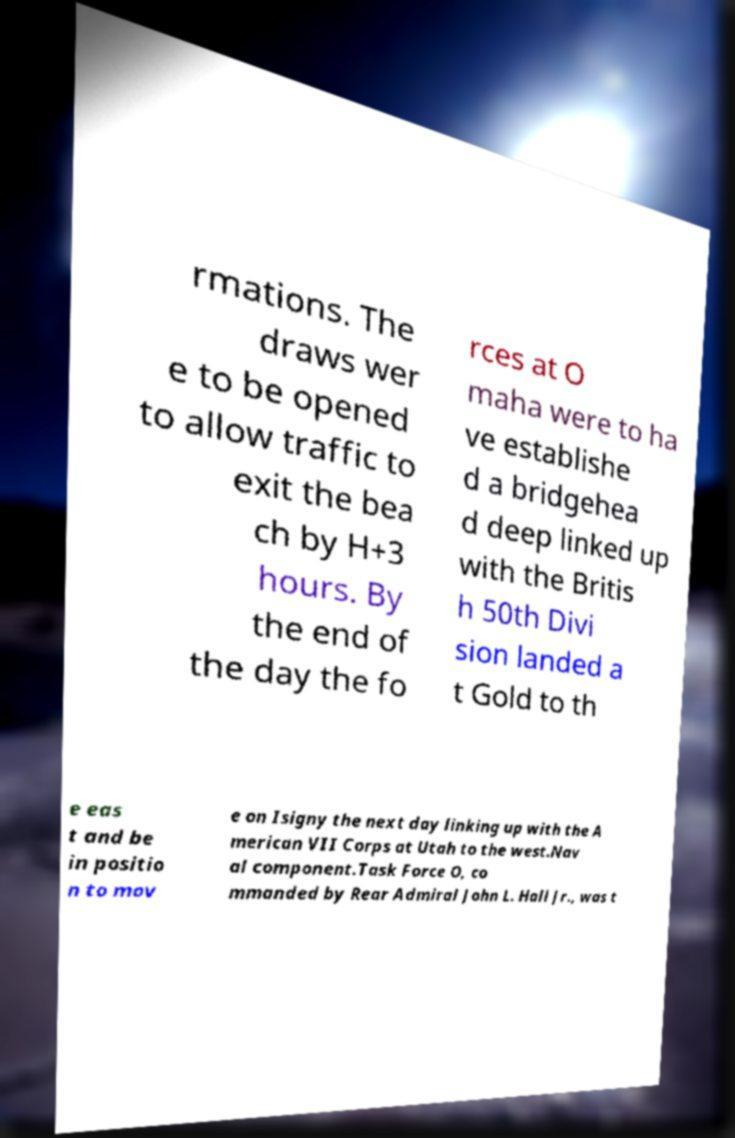Please identify and transcribe the text found in this image. rmations. The draws wer e to be opened to allow traffic to exit the bea ch by H+3 hours. By the end of the day the fo rces at O maha were to ha ve establishe d a bridgehea d deep linked up with the Britis h 50th Divi sion landed a t Gold to th e eas t and be in positio n to mov e on Isigny the next day linking up with the A merican VII Corps at Utah to the west.Nav al component.Task Force O, co mmanded by Rear Admiral John L. Hall Jr., was t 